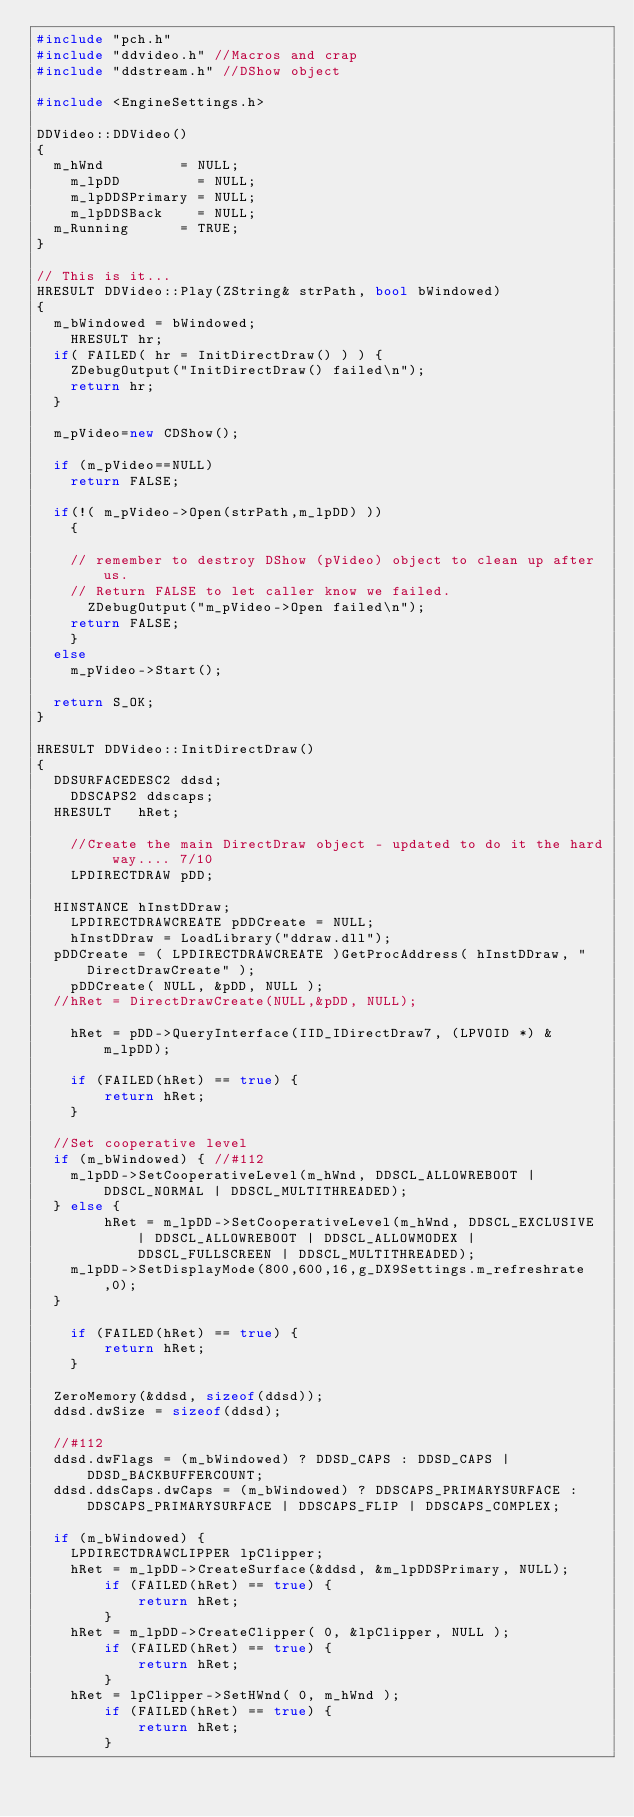<code> <loc_0><loc_0><loc_500><loc_500><_C++_>#include "pch.h"
#include "ddvideo.h" //Macros and crap
#include "ddstream.h" //DShow object

#include <EngineSettings.h>

DDVideo::DDVideo()
{
	m_hWnd         = NULL;
    m_lpDD         = NULL;
    m_lpDDSPrimary = NULL;
    m_lpDDSBack    = NULL;
	m_Running      = TRUE; 
}

// This is it...
HRESULT DDVideo::Play(ZString& strPath, bool bWindowed)
{
	m_bWindowed = bWindowed;
    HRESULT hr;  
	if( FAILED( hr = InitDirectDraw() ) ) {
		ZDebugOutput("InitDirectDraw() failed\n");
		return hr;
	}

	m_pVideo=new CDShow();

	if (m_pVideo==NULL) 
		return FALSE;	                 
    	
	if(!( m_pVideo->Open(strPath,m_lpDD) ))
		{
	
		// remember to destroy DShow (pVideo) object to clean up after us.
		// Return FALSE to let caller know we failed.
			ZDebugOutput("m_pVideo->Open failed\n");
		return FALSE;
		}			
	else
		m_pVideo->Start();     

	return S_OK;
}

HRESULT DDVideo::InitDirectDraw()
{
	DDSURFACEDESC2 ddsd;
    DDSCAPS2 ddscaps;
	HRESULT		hRet;
 
    //Create the main DirectDraw object - updated to do it the hard way.... 7/10
    LPDIRECTDRAW pDD;

	HINSTANCE hInstDDraw;
    LPDIRECTDRAWCREATE pDDCreate = NULL;
    hInstDDraw = LoadLibrary("ddraw.dll");
	pDDCreate = ( LPDIRECTDRAWCREATE )GetProcAddress( hInstDDraw, "DirectDrawCreate" );
    pDDCreate( NULL, &pDD, NULL );
	//hRet = DirectDrawCreate(NULL,&pDD, NULL);

    hRet = pDD->QueryInterface(IID_IDirectDraw7, (LPVOID *) & m_lpDD);

    if (FAILED(hRet) == true) {
        return hRet;
    }
      
	//Set cooperative level
	if (m_bWindowed) { //#112
		m_lpDD->SetCooperativeLevel(m_hWnd, DDSCL_ALLOWREBOOT | DDSCL_NORMAL | DDSCL_MULTITHREADED);
	} else {
        hRet = m_lpDD->SetCooperativeLevel(m_hWnd, DDSCL_EXCLUSIVE | DDSCL_ALLOWREBOOT | DDSCL_ALLOWMODEX | DDSCL_FULLSCREEN | DDSCL_MULTITHREADED);
		m_lpDD->SetDisplayMode(800,600,16,g_DX9Settings.m_refreshrate,0);
	}

    if (FAILED(hRet) == true) {
        return hRet;
    }
	
	ZeroMemory(&ddsd, sizeof(ddsd));
	ddsd.dwSize = sizeof(ddsd);
	
	//#112
	ddsd.dwFlags = (m_bWindowed) ? DDSD_CAPS : DDSD_CAPS | DDSD_BACKBUFFERCOUNT;
	ddsd.ddsCaps.dwCaps = (m_bWindowed) ? DDSCAPS_PRIMARYSURFACE : DDSCAPS_PRIMARYSURFACE | DDSCAPS_FLIP | DDSCAPS_COMPLEX;

	if (m_bWindowed) {
		LPDIRECTDRAWCLIPPER lpClipper;
		hRet = m_lpDD->CreateSurface(&ddsd, &m_lpDDSPrimary, NULL);
        if (FAILED(hRet) == true) {
            return hRet;
        }
		hRet = m_lpDD->CreateClipper( 0, &lpClipper, NULL );
        if (FAILED(hRet) == true) {
            return hRet;
        }
		hRet = lpClipper->SetHWnd( 0, m_hWnd );
        if (FAILED(hRet) == true) {
            return hRet;
        }</code> 